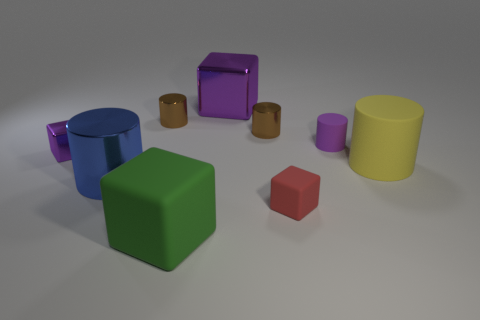The large metallic object that is left of the green cube has what shape?
Make the answer very short. Cylinder. The blue cylinder that is made of the same material as the big purple cube is what size?
Provide a short and direct response. Large. How many other large purple objects are the same shape as the big purple object?
Your answer should be very brief. 0. Does the matte thing that is right of the purple cylinder have the same color as the big metallic cube?
Provide a succinct answer. No. How many large blue metallic things are in front of the tiny rubber thing behind the small purple thing to the left of the small purple rubber cylinder?
Your answer should be very brief. 1. What number of small things are both to the right of the blue metallic cylinder and left of the blue metallic thing?
Offer a very short reply. 0. There is a metallic thing that is the same color as the big shiny cube; what shape is it?
Give a very brief answer. Cube. Are there any other things that are the same material as the green object?
Your answer should be very brief. Yes. Do the yellow cylinder and the tiny red cube have the same material?
Give a very brief answer. Yes. What shape is the tiny purple thing right of the shiny block that is on the left side of the big block that is behind the large yellow rubber cylinder?
Ensure brevity in your answer.  Cylinder. 